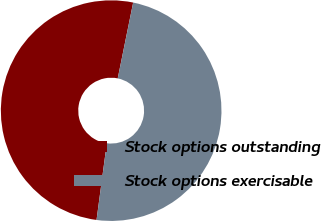<chart> <loc_0><loc_0><loc_500><loc_500><pie_chart><fcel>Stock options outstanding<fcel>Stock options exercisable<nl><fcel>51.08%<fcel>48.92%<nl></chart> 